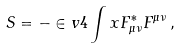<formula> <loc_0><loc_0><loc_500><loc_500>S & = - \in v { 4 } \int x F _ { \mu \nu } ^ { * } F ^ { \mu \nu } \, ,</formula> 